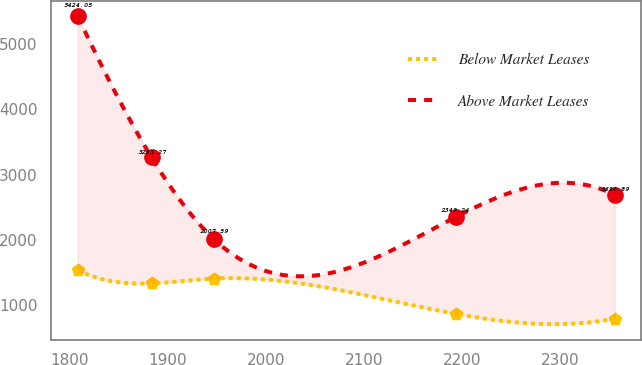<chart> <loc_0><loc_0><loc_500><loc_500><line_chart><ecel><fcel>Below Market Leases<fcel>Above Market Leases<nl><fcel>1807.89<fcel>1533.73<fcel>5424.05<nl><fcel>1883.1<fcel>1333.98<fcel>3263.27<nl><fcel>1947.03<fcel>1408.04<fcel>2007.59<nl><fcel>2193.28<fcel>867.17<fcel>2349.24<nl><fcel>2355.49<fcel>793.11<fcel>2690.89<nl></chart> 